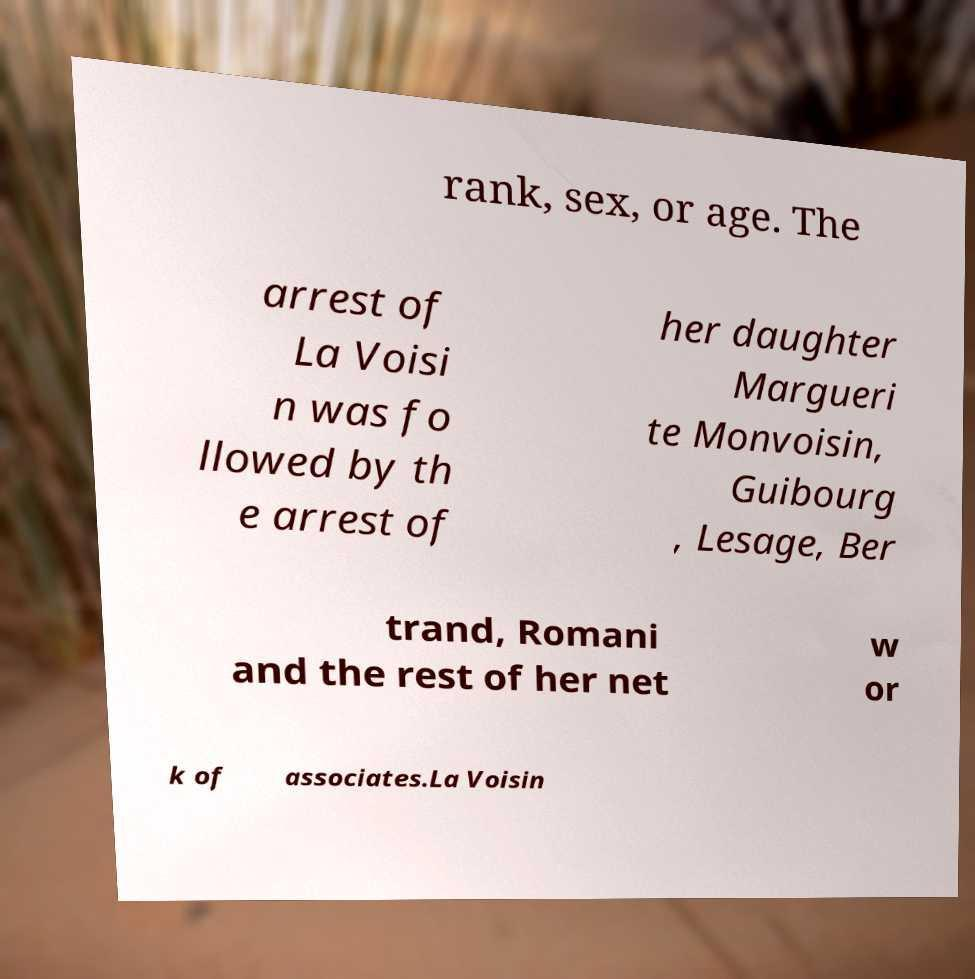For documentation purposes, I need the text within this image transcribed. Could you provide that? rank, sex, or age. The arrest of La Voisi n was fo llowed by th e arrest of her daughter Margueri te Monvoisin, Guibourg , Lesage, Ber trand, Romani and the rest of her net w or k of associates.La Voisin 